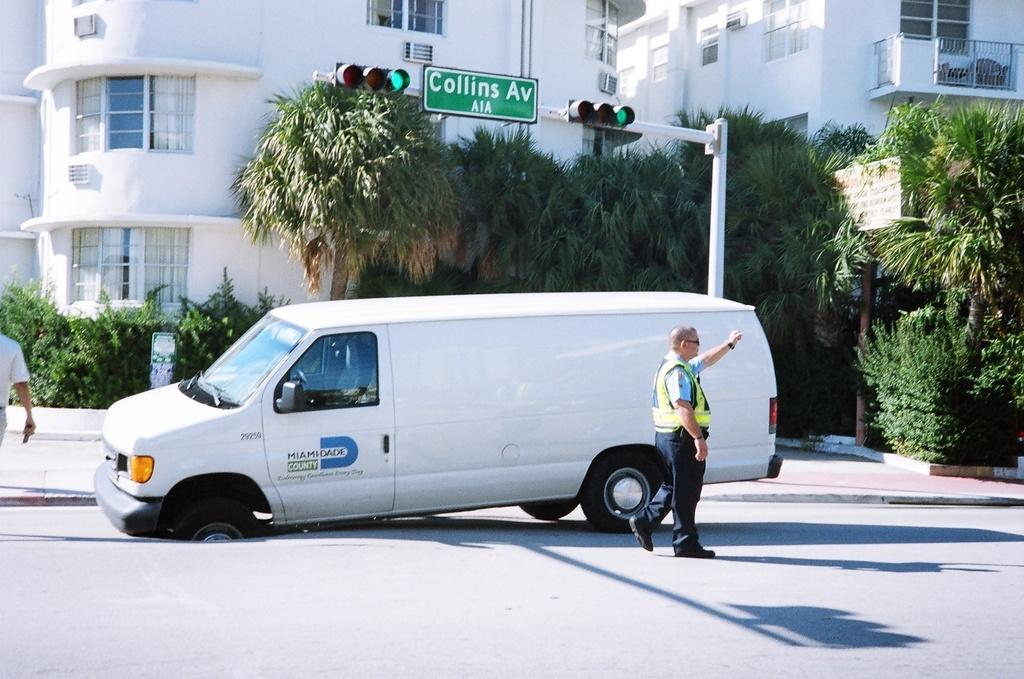Provide a one-sentence caption for the provided image. A white van with a flat tire and Miami Dade written on it. 